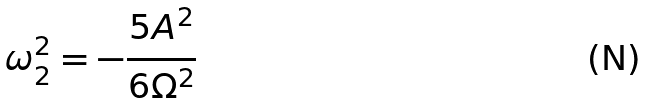<formula> <loc_0><loc_0><loc_500><loc_500>\omega _ { 2 } ^ { 2 } = - \frac { 5 A ^ { 2 } } { 6 \Omega ^ { 2 } }</formula> 